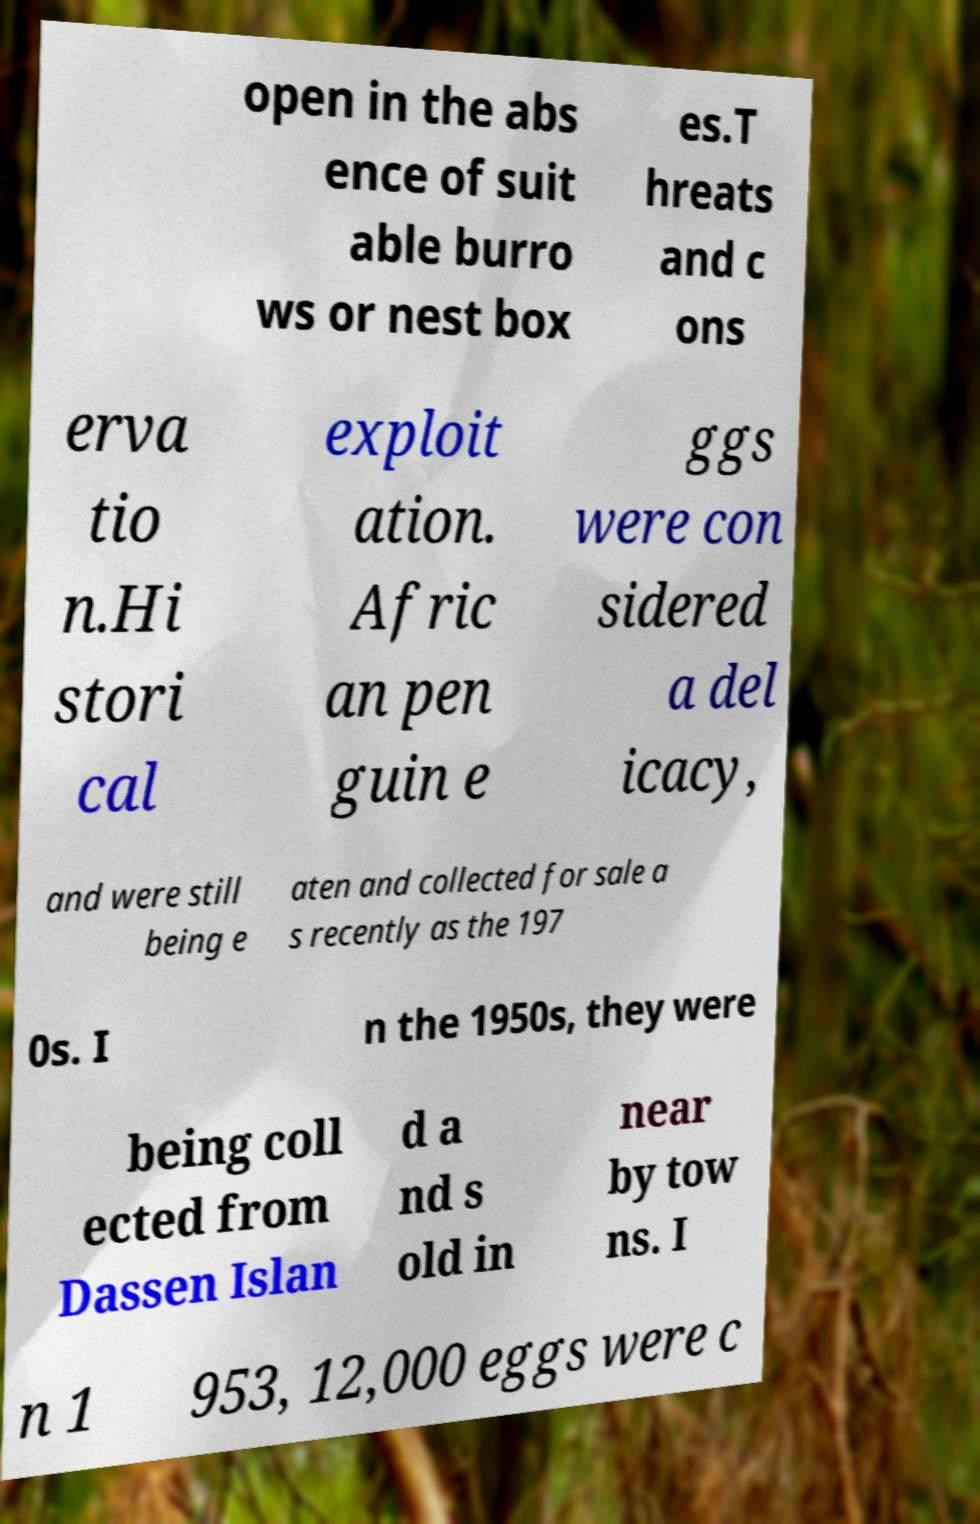Can you read and provide the text displayed in the image?This photo seems to have some interesting text. Can you extract and type it out for me? open in the abs ence of suit able burro ws or nest box es.T hreats and c ons erva tio n.Hi stori cal exploit ation. Afric an pen guin e ggs were con sidered a del icacy, and were still being e aten and collected for sale a s recently as the 197 0s. I n the 1950s, they were being coll ected from Dassen Islan d a nd s old in near by tow ns. I n 1 953, 12,000 eggs were c 